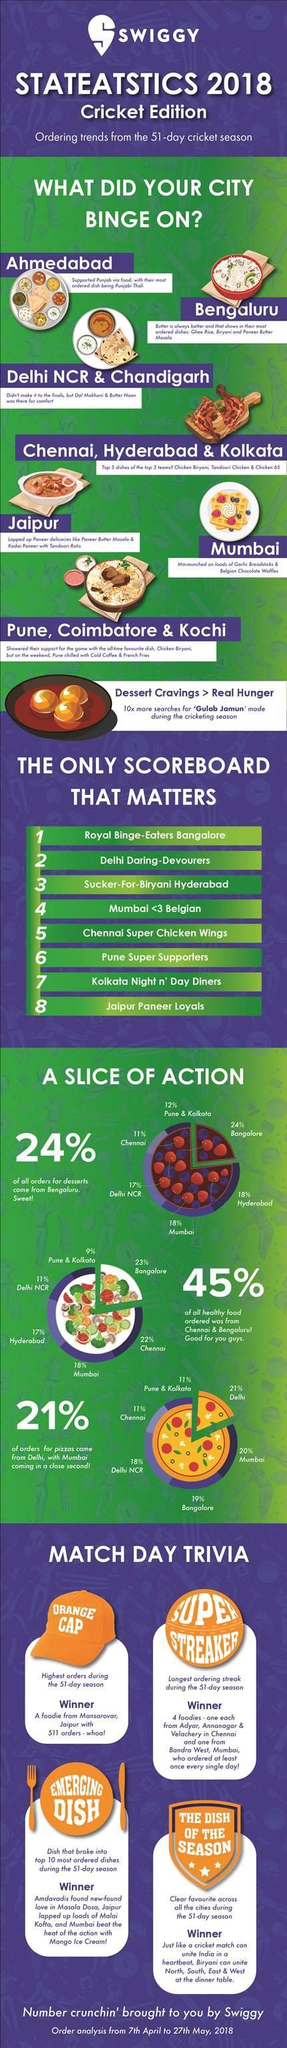Highlight a few significant elements in this photo. Approximately 38% of pizza orders come from Mumbai and Delhi combined. A total of 36% of the dessert orders came from Mumbai and Hyderabad, when combined. According to the given information, approximately 25% of the total dessert orders were placed by customers from Mumbai and Delhi. In total, the combined percentage of dessert orders from Bangalore and Hyderabad was 42%. A total of 29% of healthy food orders came from Mumbai and Delhi combined. 